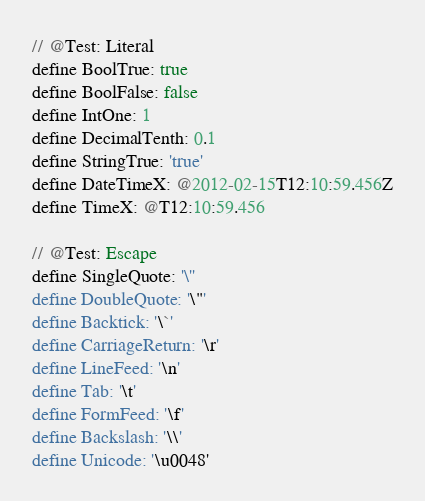<code> <loc_0><loc_0><loc_500><loc_500><_SQL_>// @Test: Literal
define BoolTrue: true
define BoolFalse: false
define IntOne: 1
define DecimalTenth: 0.1
define StringTrue: 'true'
define DateTimeX: @2012-02-15T12:10:59.456Z
define TimeX: @T12:10:59.456

// @Test: Escape
define SingleQuote: '\''
define DoubleQuote: '\"'
define Backtick: '\`'
define CarriageReturn: '\r'
define LineFeed: '\n'
define Tab: '\t'
define FormFeed: '\f'
define Backslash: '\\'
define Unicode: '\u0048'</code> 